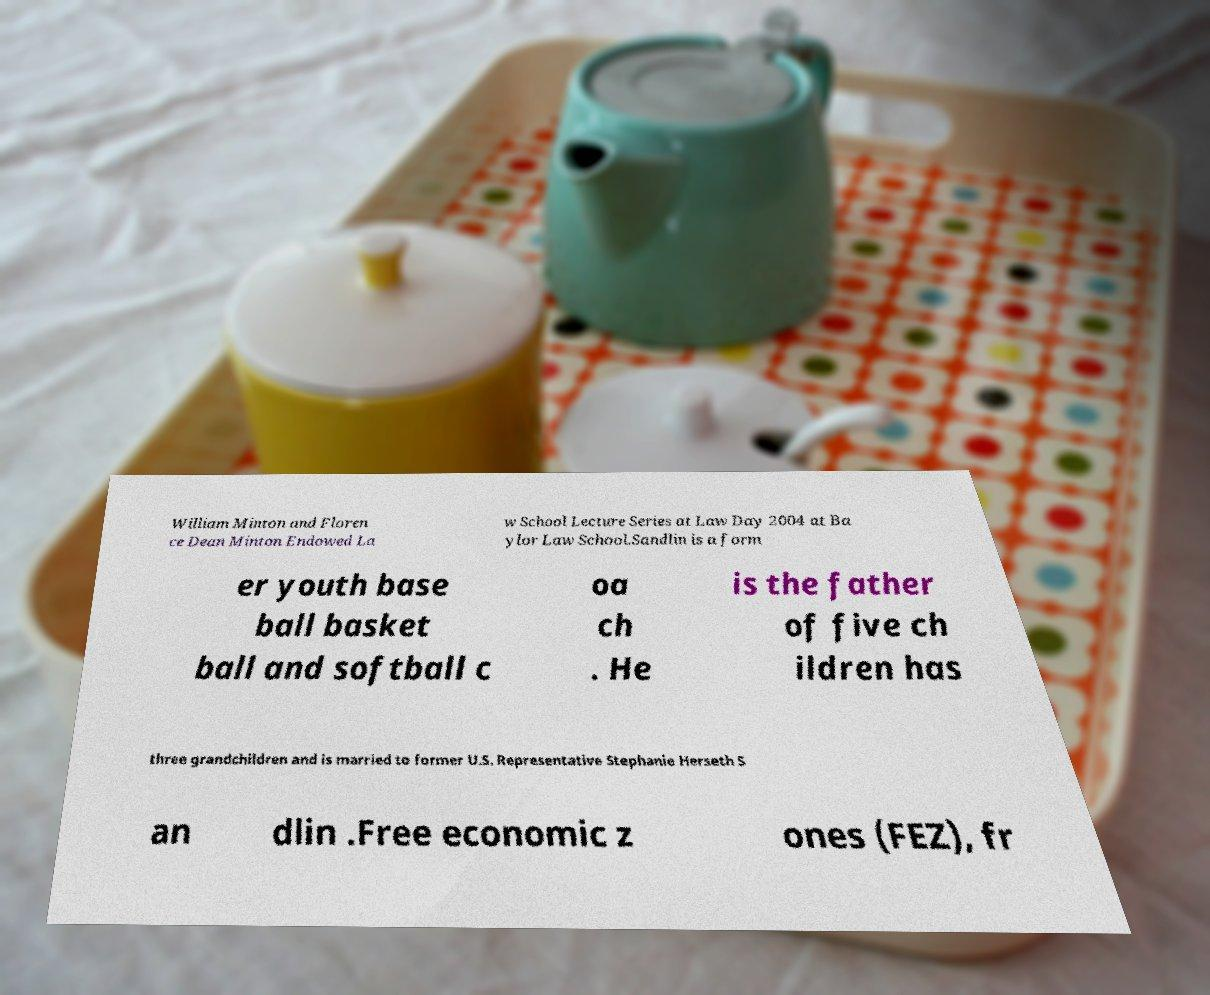Could you assist in decoding the text presented in this image and type it out clearly? William Minton and Floren ce Dean Minton Endowed La w School Lecture Series at Law Day 2004 at Ba ylor Law School.Sandlin is a form er youth base ball basket ball and softball c oa ch . He is the father of five ch ildren has three grandchildren and is married to former U.S. Representative Stephanie Herseth S an dlin .Free economic z ones (FEZ), fr 